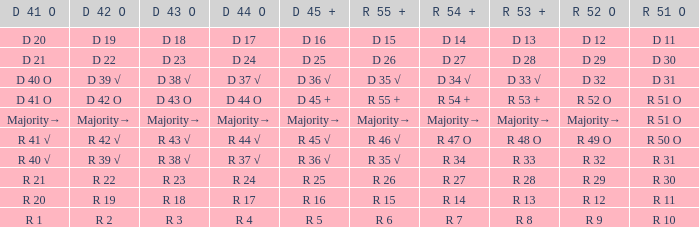Which R 51 O value corresponds to a D 42 O value of r 19? R 11. 